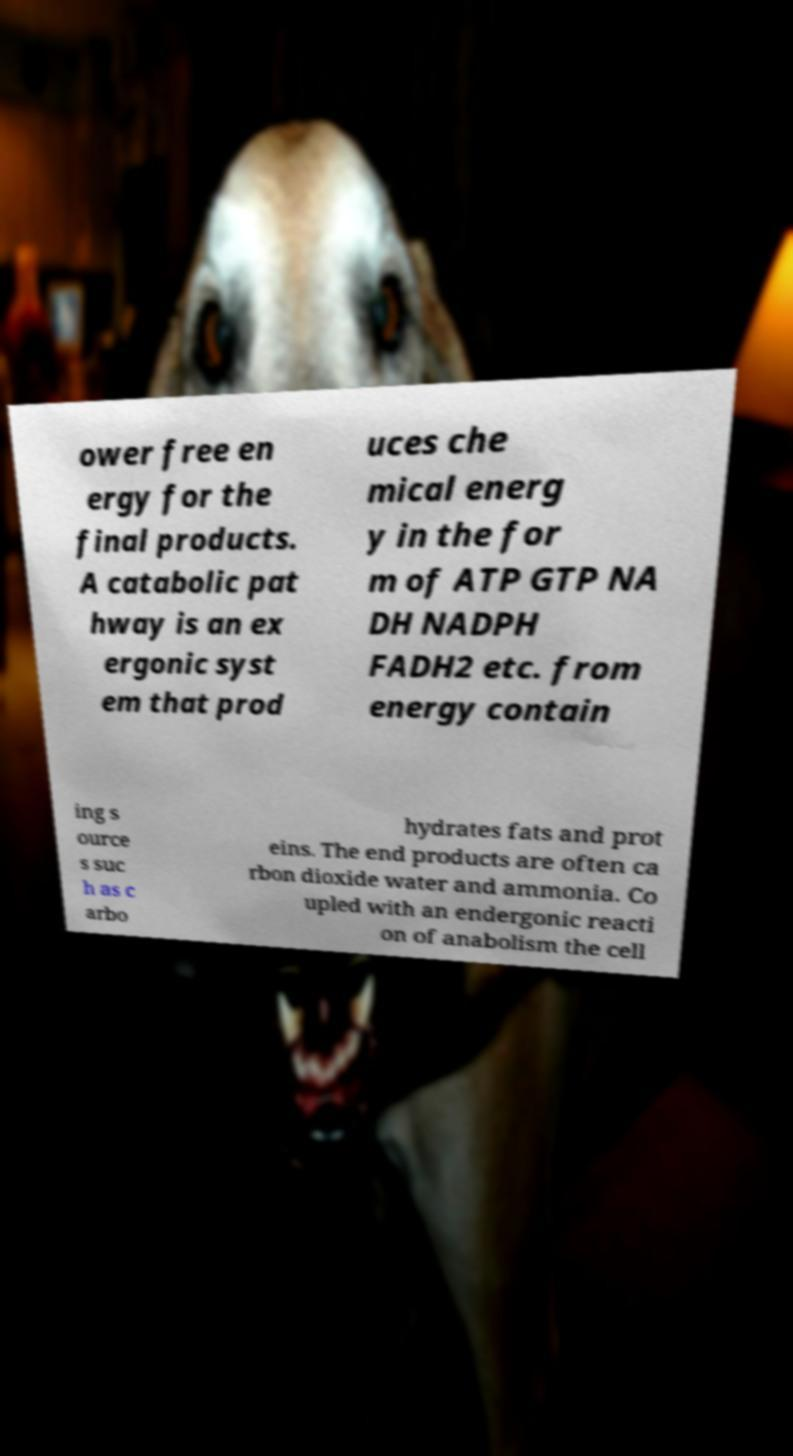Could you extract and type out the text from this image? ower free en ergy for the final products. A catabolic pat hway is an ex ergonic syst em that prod uces che mical energ y in the for m of ATP GTP NA DH NADPH FADH2 etc. from energy contain ing s ource s suc h as c arbo hydrates fats and prot eins. The end products are often ca rbon dioxide water and ammonia. Co upled with an endergonic reacti on of anabolism the cell 